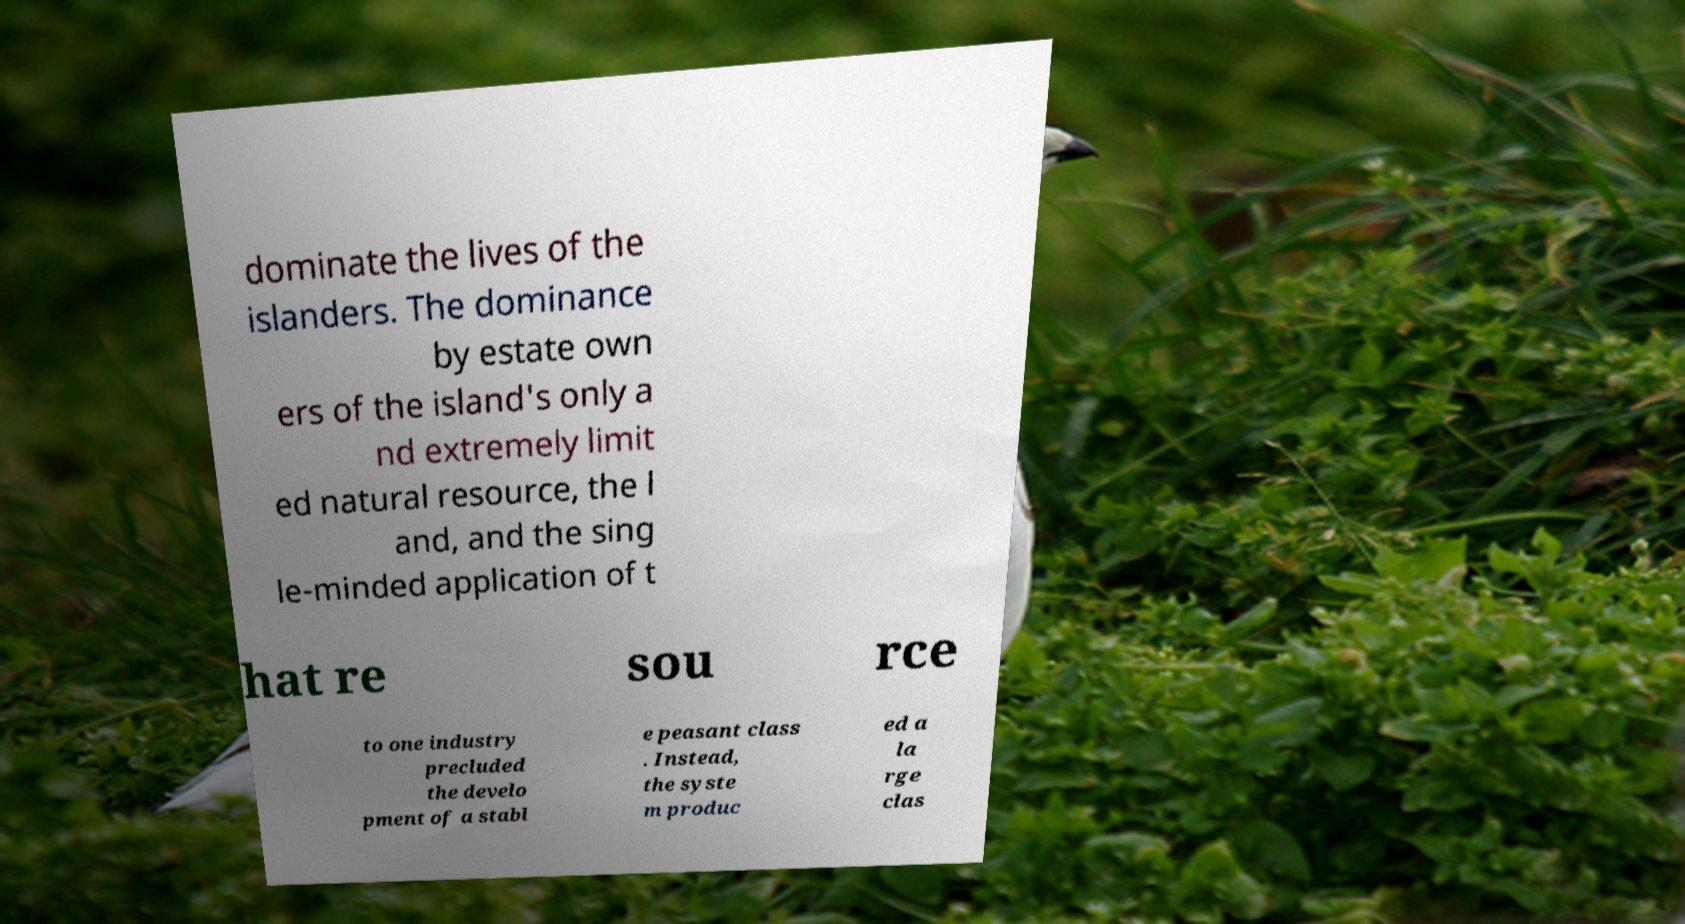There's text embedded in this image that I need extracted. Can you transcribe it verbatim? dominate the lives of the islanders. The dominance by estate own ers of the island's only a nd extremely limit ed natural resource, the l and, and the sing le-minded application of t hat re sou rce to one industry precluded the develo pment of a stabl e peasant class . Instead, the syste m produc ed a la rge clas 